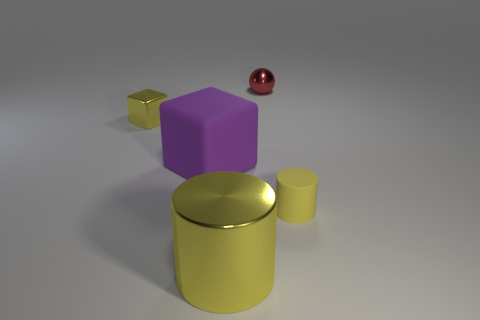Add 3 tiny cyan matte blocks. How many objects exist? 8 Subtract all cubes. How many objects are left? 3 Add 5 large purple blocks. How many large purple blocks exist? 6 Subtract 0 cyan cubes. How many objects are left? 5 Subtract all cylinders. Subtract all red shiny balls. How many objects are left? 2 Add 1 cubes. How many cubes are left? 3 